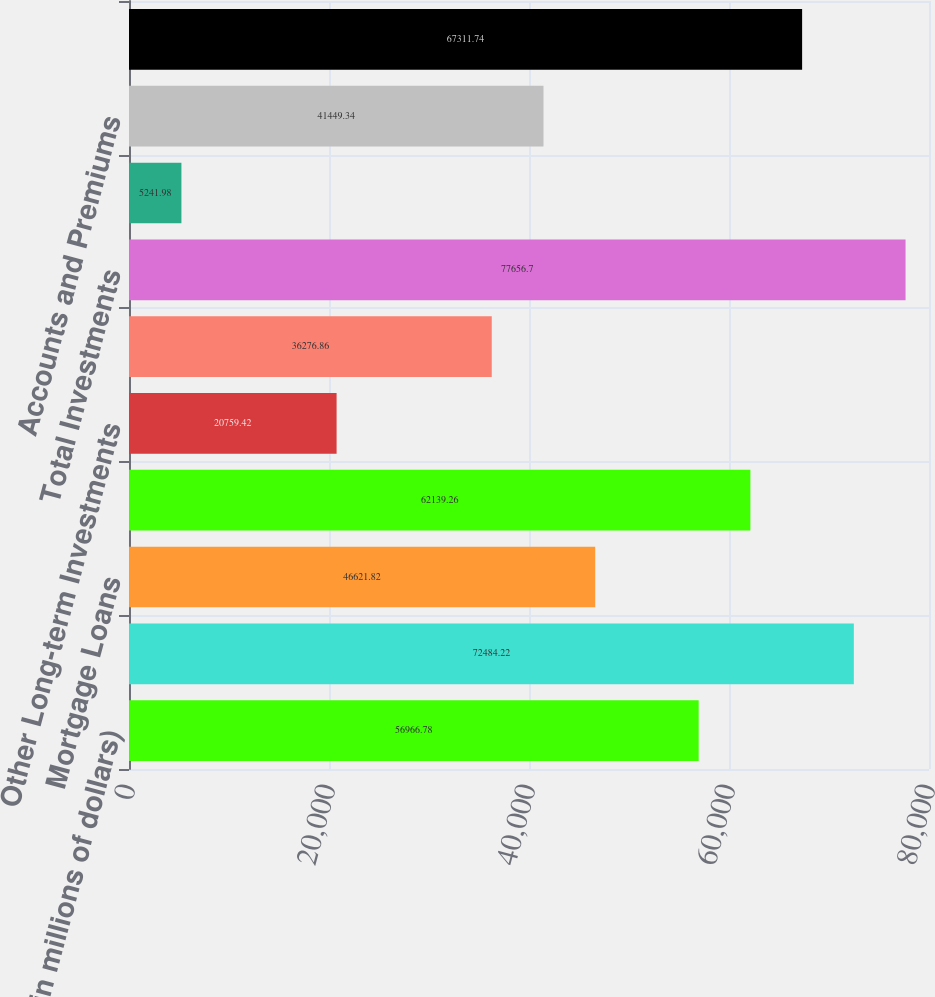Convert chart to OTSL. <chart><loc_0><loc_0><loc_500><loc_500><bar_chart><fcel>(in millions of dollars)<fcel>Fixed Maturity Securities - at<fcel>Mortgage Loans<fcel>Policy Loans<fcel>Other Long-term Investments<fcel>Short-term Investments<fcel>Total Investments<fcel>Cash and Bank Deposits<fcel>Accounts and Premiums<fcel>Reinsurance Recoverable<nl><fcel>56966.8<fcel>72484.2<fcel>46621.8<fcel>62139.3<fcel>20759.4<fcel>36276.9<fcel>77656.7<fcel>5241.98<fcel>41449.3<fcel>67311.7<nl></chart> 